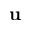<formula> <loc_0><loc_0><loc_500><loc_500>u</formula> 